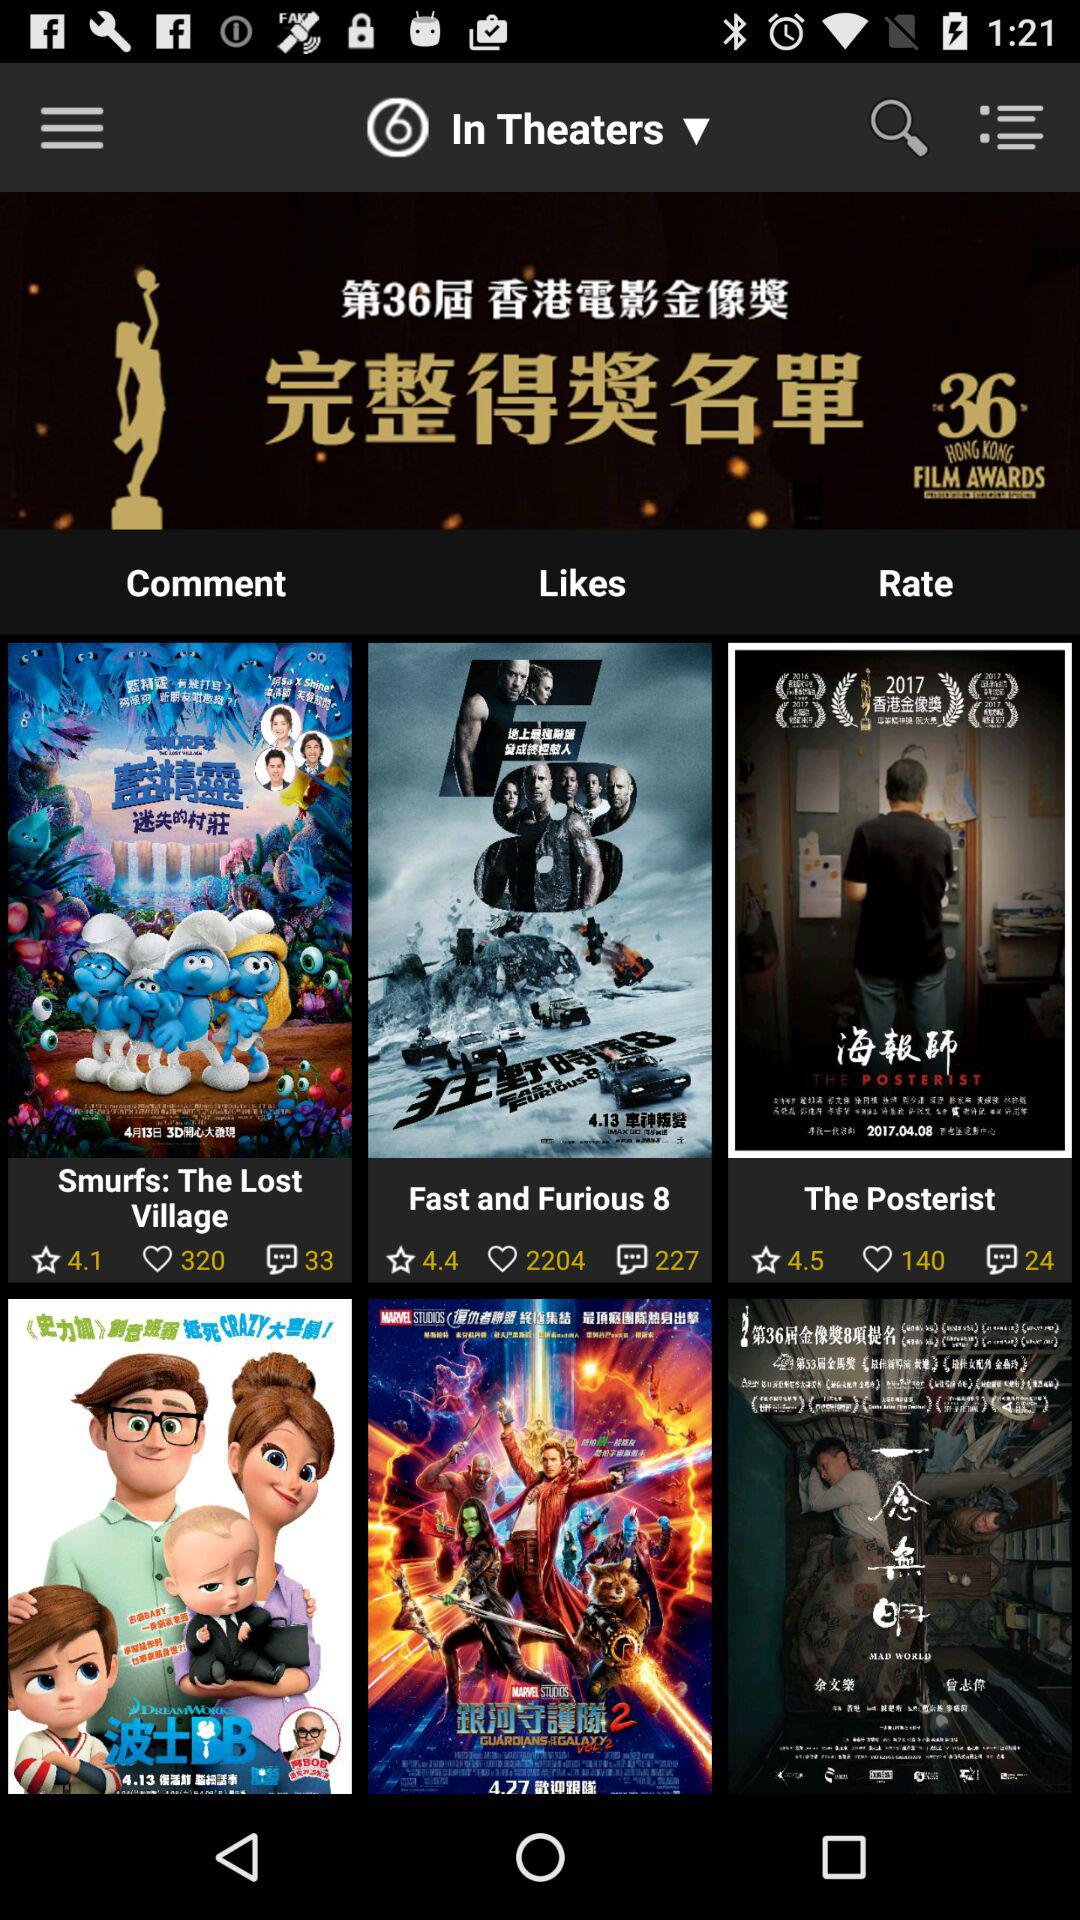How many likes are there of "Fast and Furious 8"? There are 2204 likes of "Fast and Furious 8". 